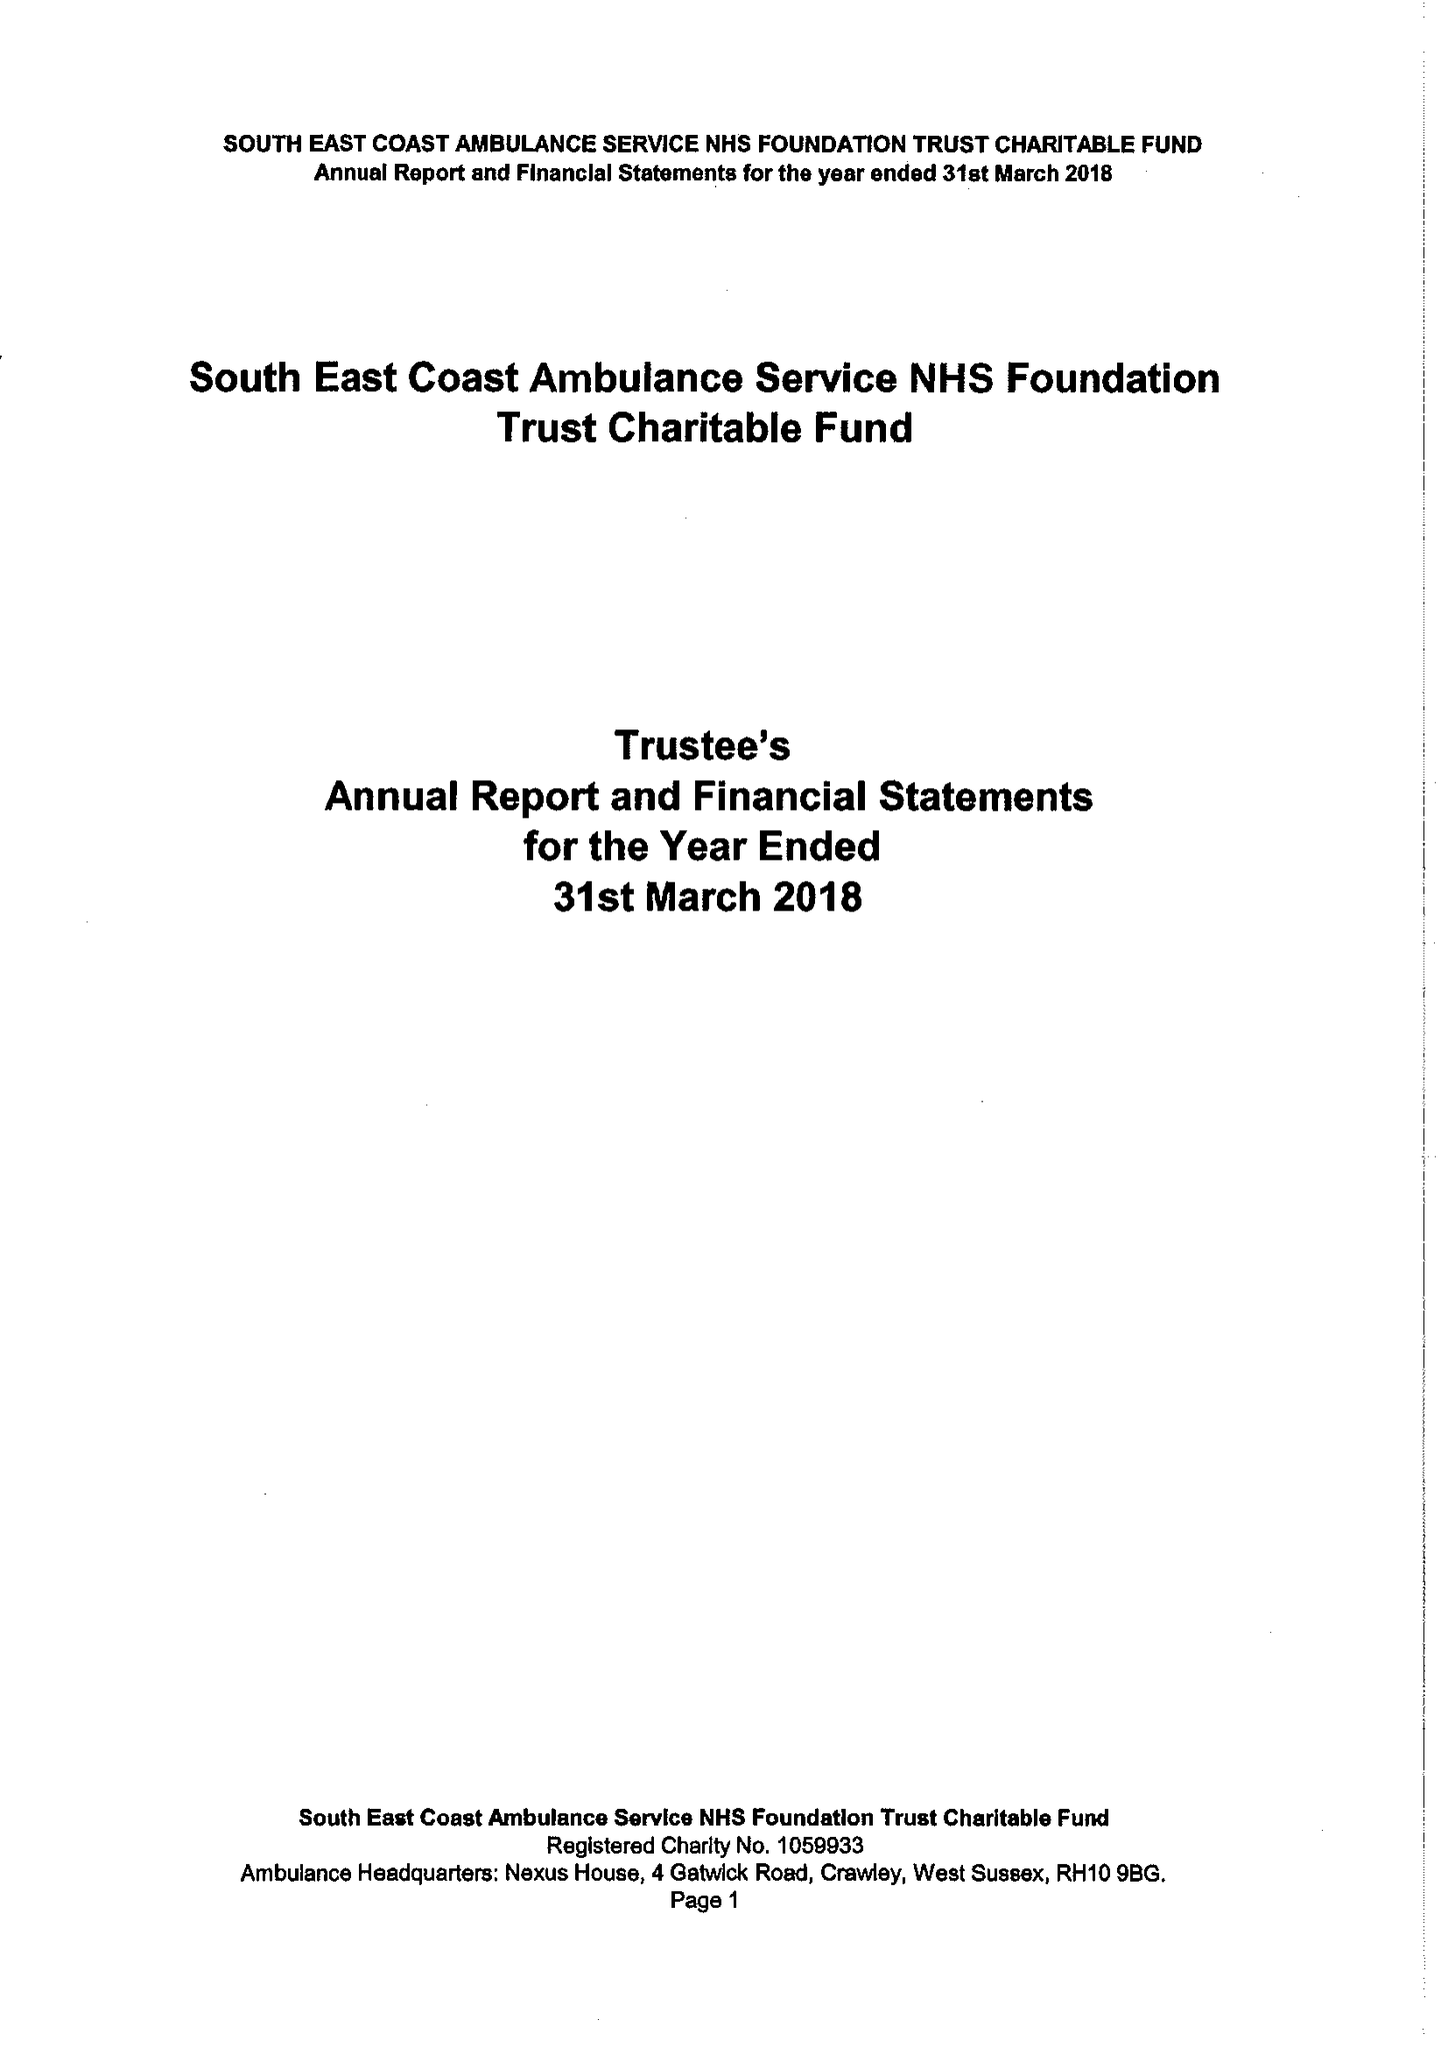What is the value for the income_annually_in_british_pounds?
Answer the question using a single word or phrase. 100000.00 